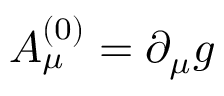<formula> <loc_0><loc_0><loc_500><loc_500>A _ { \mu } ^ { ( 0 ) } = \partial _ { \mu } g</formula> 